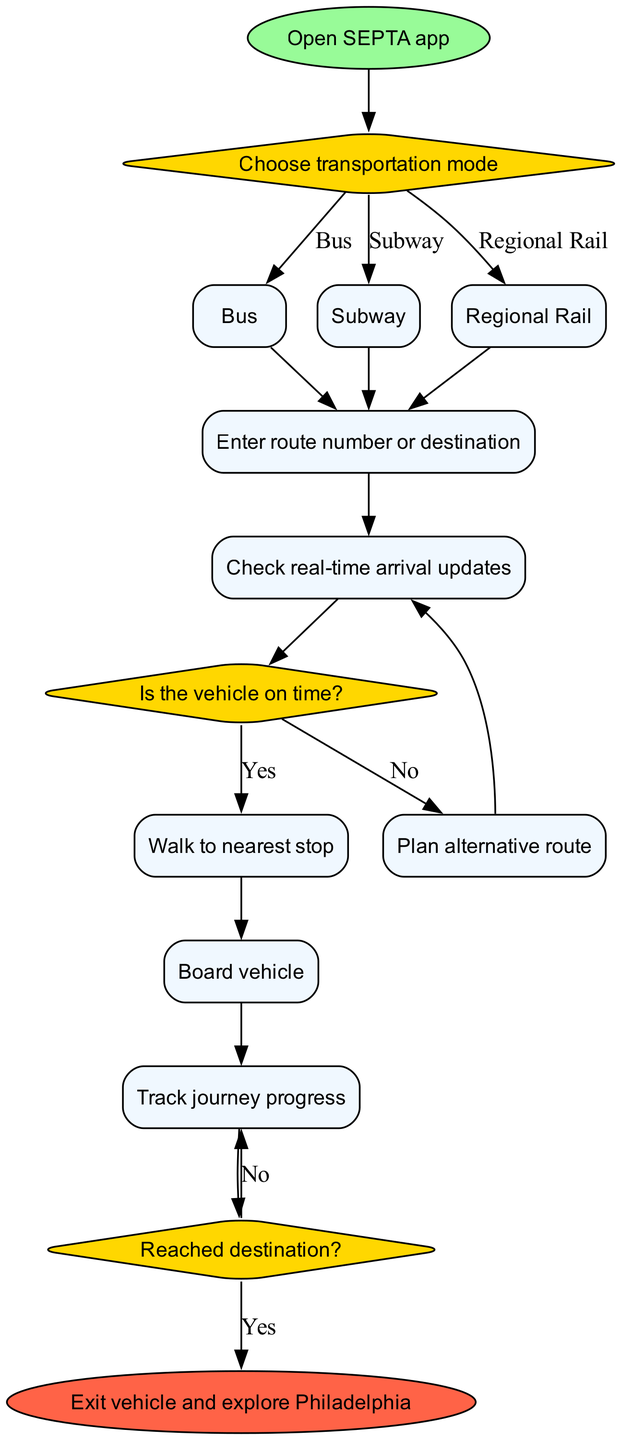What is the first action to take in this flowchart? The diagram starts with the node labeled "Open SEPTA app," indicating that this is the initial action in the process.
Answer: Open SEPTA app How many options are presented for transportation mode? The diagram shows three options leading from the node "Choose transportation mode," labeled as "Bus," "Subway," and "Regional Rail," indicating a total of three options.
Answer: 3 What happens if the vehicle is on time? If the vehicle is on time, according to the decision point "Is the vehicle on time?" there is an edge leading to the action labeled "Walk to nearest stop."
Answer: Walk to nearest stop What action follows after "Check real-time arrival updates"? The flow from the action "Check real-time arrival updates" goes to the decision "Is the vehicle on time?", indicating that this is the next step in the process.
Answer: Is the vehicle on time? If the vehicle is not on time, what is the next action to take? After the decision labeled "Is the vehicle on time?" if the answer is "No," the next action is to "Plan alternative route." This is indicated by the edge leading away from the decision towards this action.
Answer: Plan alternative route What is the final action when the journey is complete? The last node in the flowchart is labeled "Exit vehicle and explore Philadelphia," which indicates what the user does upon arriving at their destination.
Answer: Exit vehicle and explore Philadelphia How do you begin navigating the public transportation system in Philadelphia? The flowchart indicates that the process starts with the "Open SEPTA app," clearly showing this as the first necessary step for navigation.
Answer: Open SEPTA app What must be done after entering the route number or destination? Following the action "Enter route number or destination," the next action to perform is to "Check real-time arrival updates," indicating a sequential step in the process.
Answer: Check real-time arrival updates What decision must be made after tracking journey progress? After "Track journey progress," the user must determine if they have "Reached destination?" This decision point specifies whether to continue tracking or proceed to exit.
Answer: Reached destination? 